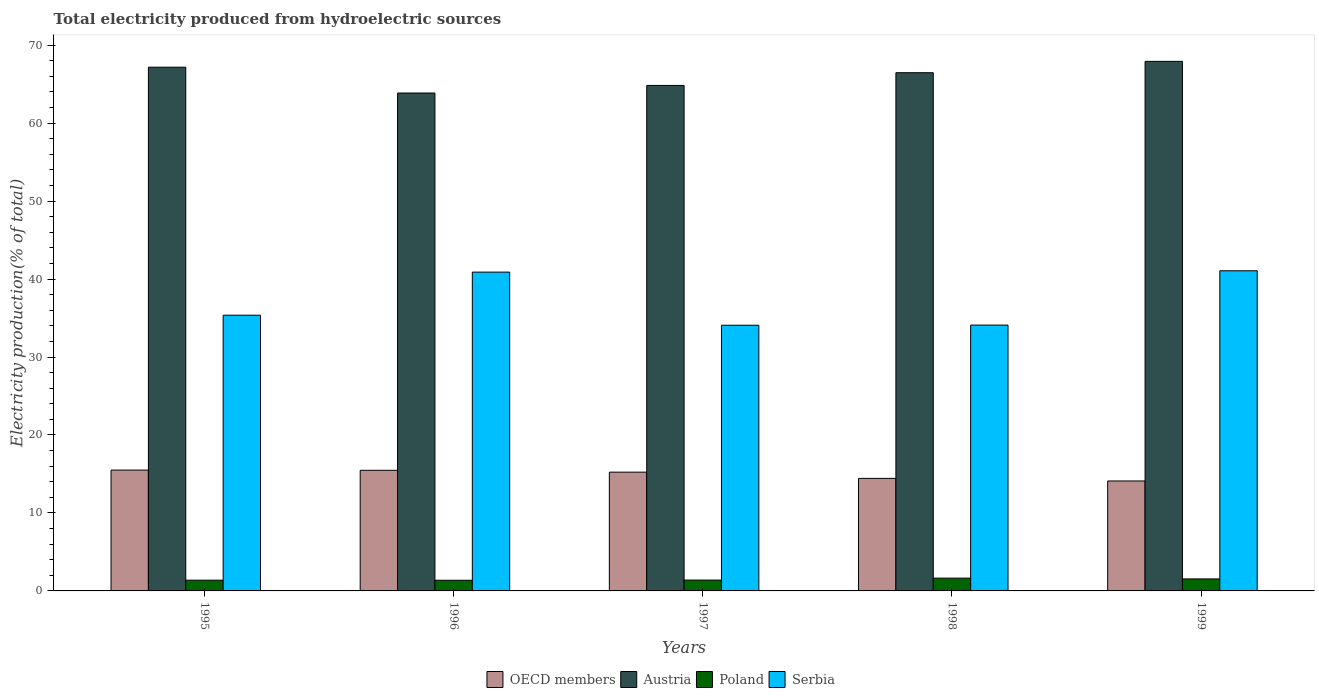Are the number of bars on each tick of the X-axis equal?
Make the answer very short. Yes. How many bars are there on the 3rd tick from the left?
Offer a terse response. 4. What is the label of the 1st group of bars from the left?
Ensure brevity in your answer.  1995. In how many cases, is the number of bars for a given year not equal to the number of legend labels?
Provide a succinct answer. 0. What is the total electricity produced in Poland in 1996?
Keep it short and to the point. 1.37. Across all years, what is the maximum total electricity produced in Poland?
Your answer should be very brief. 1.64. Across all years, what is the minimum total electricity produced in Serbia?
Your response must be concise. 34.08. In which year was the total electricity produced in Serbia maximum?
Give a very brief answer. 1999. What is the total total electricity produced in Poland in the graph?
Your answer should be compact. 7.32. What is the difference between the total electricity produced in Poland in 1996 and that in 1999?
Give a very brief answer. -0.17. What is the difference between the total electricity produced in Poland in 1997 and the total electricity produced in Serbia in 1996?
Provide a short and direct response. -39.5. What is the average total electricity produced in OECD members per year?
Offer a terse response. 14.95. In the year 1995, what is the difference between the total electricity produced in Poland and total electricity produced in OECD members?
Provide a succinct answer. -14.12. What is the ratio of the total electricity produced in Austria in 1996 to that in 1999?
Provide a succinct answer. 0.94. Is the total electricity produced in Serbia in 1997 less than that in 1999?
Provide a short and direct response. Yes. Is the difference between the total electricity produced in Poland in 1995 and 1997 greater than the difference between the total electricity produced in OECD members in 1995 and 1997?
Your answer should be compact. No. What is the difference between the highest and the second highest total electricity produced in Austria?
Offer a very short reply. 0.75. What is the difference between the highest and the lowest total electricity produced in OECD members?
Offer a terse response. 1.4. In how many years, is the total electricity produced in Serbia greater than the average total electricity produced in Serbia taken over all years?
Your response must be concise. 2. Is the sum of the total electricity produced in Poland in 1997 and 1998 greater than the maximum total electricity produced in OECD members across all years?
Your answer should be very brief. No. What does the 1st bar from the right in 1997 represents?
Your response must be concise. Serbia. Is it the case that in every year, the sum of the total electricity produced in Poland and total electricity produced in Serbia is greater than the total electricity produced in Austria?
Your response must be concise. No. Are all the bars in the graph horizontal?
Your response must be concise. No. What is the difference between two consecutive major ticks on the Y-axis?
Ensure brevity in your answer.  10. Does the graph contain grids?
Ensure brevity in your answer.  No. How many legend labels are there?
Offer a very short reply. 4. How are the legend labels stacked?
Provide a succinct answer. Horizontal. What is the title of the graph?
Make the answer very short. Total electricity produced from hydroelectric sources. What is the label or title of the X-axis?
Keep it short and to the point. Years. What is the Electricity production(% of total) of OECD members in 1995?
Offer a terse response. 15.5. What is the Electricity production(% of total) in Austria in 1995?
Your answer should be compact. 67.18. What is the Electricity production(% of total) of Poland in 1995?
Your response must be concise. 1.38. What is the Electricity production(% of total) of Serbia in 1995?
Offer a very short reply. 35.37. What is the Electricity production(% of total) of OECD members in 1996?
Provide a short and direct response. 15.47. What is the Electricity production(% of total) in Austria in 1996?
Provide a succinct answer. 63.87. What is the Electricity production(% of total) of Poland in 1996?
Your answer should be compact. 1.37. What is the Electricity production(% of total) of Serbia in 1996?
Provide a succinct answer. 40.89. What is the Electricity production(% of total) of OECD members in 1997?
Make the answer very short. 15.24. What is the Electricity production(% of total) of Austria in 1997?
Offer a very short reply. 64.84. What is the Electricity production(% of total) of Poland in 1997?
Ensure brevity in your answer.  1.39. What is the Electricity production(% of total) of Serbia in 1997?
Offer a very short reply. 34.08. What is the Electricity production(% of total) in OECD members in 1998?
Provide a succinct answer. 14.44. What is the Electricity production(% of total) in Austria in 1998?
Offer a very short reply. 66.47. What is the Electricity production(% of total) in Poland in 1998?
Give a very brief answer. 1.64. What is the Electricity production(% of total) of Serbia in 1998?
Keep it short and to the point. 34.1. What is the Electricity production(% of total) in OECD members in 1999?
Ensure brevity in your answer.  14.1. What is the Electricity production(% of total) of Austria in 1999?
Give a very brief answer. 67.93. What is the Electricity production(% of total) of Poland in 1999?
Give a very brief answer. 1.54. What is the Electricity production(% of total) of Serbia in 1999?
Your response must be concise. 41.07. Across all years, what is the maximum Electricity production(% of total) of OECD members?
Offer a terse response. 15.5. Across all years, what is the maximum Electricity production(% of total) of Austria?
Provide a short and direct response. 67.93. Across all years, what is the maximum Electricity production(% of total) of Poland?
Your answer should be very brief. 1.64. Across all years, what is the maximum Electricity production(% of total) in Serbia?
Give a very brief answer. 41.07. Across all years, what is the minimum Electricity production(% of total) in OECD members?
Give a very brief answer. 14.1. Across all years, what is the minimum Electricity production(% of total) in Austria?
Offer a very short reply. 63.87. Across all years, what is the minimum Electricity production(% of total) in Poland?
Provide a succinct answer. 1.37. Across all years, what is the minimum Electricity production(% of total) in Serbia?
Your answer should be very brief. 34.08. What is the total Electricity production(% of total) of OECD members in the graph?
Your response must be concise. 74.75. What is the total Electricity production(% of total) in Austria in the graph?
Your answer should be compact. 330.28. What is the total Electricity production(% of total) in Poland in the graph?
Keep it short and to the point. 7.32. What is the total Electricity production(% of total) of Serbia in the graph?
Your answer should be very brief. 185.5. What is the difference between the Electricity production(% of total) of OECD members in 1995 and that in 1996?
Your answer should be compact. 0.03. What is the difference between the Electricity production(% of total) in Austria in 1995 and that in 1996?
Provide a short and direct response. 3.31. What is the difference between the Electricity production(% of total) in Poland in 1995 and that in 1996?
Make the answer very short. 0.01. What is the difference between the Electricity production(% of total) of Serbia in 1995 and that in 1996?
Your response must be concise. -5.53. What is the difference between the Electricity production(% of total) of OECD members in 1995 and that in 1997?
Provide a short and direct response. 0.26. What is the difference between the Electricity production(% of total) in Austria in 1995 and that in 1997?
Provide a short and direct response. 2.34. What is the difference between the Electricity production(% of total) of Poland in 1995 and that in 1997?
Your response must be concise. -0.01. What is the difference between the Electricity production(% of total) in Serbia in 1995 and that in 1997?
Give a very brief answer. 1.29. What is the difference between the Electricity production(% of total) of OECD members in 1995 and that in 1998?
Your answer should be very brief. 1.06. What is the difference between the Electricity production(% of total) of Austria in 1995 and that in 1998?
Give a very brief answer. 0.71. What is the difference between the Electricity production(% of total) in Poland in 1995 and that in 1998?
Offer a very short reply. -0.26. What is the difference between the Electricity production(% of total) in Serbia in 1995 and that in 1998?
Provide a succinct answer. 1.27. What is the difference between the Electricity production(% of total) in OECD members in 1995 and that in 1999?
Offer a very short reply. 1.4. What is the difference between the Electricity production(% of total) of Austria in 1995 and that in 1999?
Your answer should be compact. -0.75. What is the difference between the Electricity production(% of total) of Poland in 1995 and that in 1999?
Provide a short and direct response. -0.16. What is the difference between the Electricity production(% of total) in Serbia in 1995 and that in 1999?
Your answer should be very brief. -5.7. What is the difference between the Electricity production(% of total) of OECD members in 1996 and that in 1997?
Offer a very short reply. 0.24. What is the difference between the Electricity production(% of total) of Austria in 1996 and that in 1997?
Ensure brevity in your answer.  -0.97. What is the difference between the Electricity production(% of total) of Poland in 1996 and that in 1997?
Your response must be concise. -0.02. What is the difference between the Electricity production(% of total) in Serbia in 1996 and that in 1997?
Give a very brief answer. 6.81. What is the difference between the Electricity production(% of total) of OECD members in 1996 and that in 1998?
Ensure brevity in your answer.  1.04. What is the difference between the Electricity production(% of total) of Austria in 1996 and that in 1998?
Offer a very short reply. -2.6. What is the difference between the Electricity production(% of total) of Poland in 1996 and that in 1998?
Your answer should be compact. -0.27. What is the difference between the Electricity production(% of total) in Serbia in 1996 and that in 1998?
Keep it short and to the point. 6.79. What is the difference between the Electricity production(% of total) of OECD members in 1996 and that in 1999?
Make the answer very short. 1.37. What is the difference between the Electricity production(% of total) of Austria in 1996 and that in 1999?
Keep it short and to the point. -4.06. What is the difference between the Electricity production(% of total) of Poland in 1996 and that in 1999?
Your answer should be very brief. -0.17. What is the difference between the Electricity production(% of total) in Serbia in 1996 and that in 1999?
Give a very brief answer. -0.17. What is the difference between the Electricity production(% of total) in OECD members in 1997 and that in 1998?
Offer a terse response. 0.8. What is the difference between the Electricity production(% of total) in Austria in 1997 and that in 1998?
Your answer should be compact. -1.63. What is the difference between the Electricity production(% of total) in Poland in 1997 and that in 1998?
Provide a short and direct response. -0.25. What is the difference between the Electricity production(% of total) in Serbia in 1997 and that in 1998?
Keep it short and to the point. -0.02. What is the difference between the Electricity production(% of total) of OECD members in 1997 and that in 1999?
Your answer should be very brief. 1.13. What is the difference between the Electricity production(% of total) in Austria in 1997 and that in 1999?
Your response must be concise. -3.09. What is the difference between the Electricity production(% of total) in Poland in 1997 and that in 1999?
Offer a very short reply. -0.15. What is the difference between the Electricity production(% of total) in Serbia in 1997 and that in 1999?
Provide a short and direct response. -6.99. What is the difference between the Electricity production(% of total) in OECD members in 1998 and that in 1999?
Provide a short and direct response. 0.33. What is the difference between the Electricity production(% of total) of Austria in 1998 and that in 1999?
Provide a succinct answer. -1.46. What is the difference between the Electricity production(% of total) of Poland in 1998 and that in 1999?
Give a very brief answer. 0.1. What is the difference between the Electricity production(% of total) in Serbia in 1998 and that in 1999?
Offer a very short reply. -6.97. What is the difference between the Electricity production(% of total) in OECD members in 1995 and the Electricity production(% of total) in Austria in 1996?
Offer a terse response. -48.37. What is the difference between the Electricity production(% of total) in OECD members in 1995 and the Electricity production(% of total) in Poland in 1996?
Offer a very short reply. 14.13. What is the difference between the Electricity production(% of total) in OECD members in 1995 and the Electricity production(% of total) in Serbia in 1996?
Ensure brevity in your answer.  -25.39. What is the difference between the Electricity production(% of total) of Austria in 1995 and the Electricity production(% of total) of Poland in 1996?
Provide a short and direct response. 65.81. What is the difference between the Electricity production(% of total) in Austria in 1995 and the Electricity production(% of total) in Serbia in 1996?
Offer a terse response. 26.28. What is the difference between the Electricity production(% of total) in Poland in 1995 and the Electricity production(% of total) in Serbia in 1996?
Provide a succinct answer. -39.52. What is the difference between the Electricity production(% of total) in OECD members in 1995 and the Electricity production(% of total) in Austria in 1997?
Give a very brief answer. -49.34. What is the difference between the Electricity production(% of total) of OECD members in 1995 and the Electricity production(% of total) of Poland in 1997?
Your answer should be very brief. 14.11. What is the difference between the Electricity production(% of total) in OECD members in 1995 and the Electricity production(% of total) in Serbia in 1997?
Offer a terse response. -18.58. What is the difference between the Electricity production(% of total) of Austria in 1995 and the Electricity production(% of total) of Poland in 1997?
Make the answer very short. 65.79. What is the difference between the Electricity production(% of total) of Austria in 1995 and the Electricity production(% of total) of Serbia in 1997?
Offer a terse response. 33.1. What is the difference between the Electricity production(% of total) of Poland in 1995 and the Electricity production(% of total) of Serbia in 1997?
Offer a very short reply. -32.7. What is the difference between the Electricity production(% of total) of OECD members in 1995 and the Electricity production(% of total) of Austria in 1998?
Your response must be concise. -50.97. What is the difference between the Electricity production(% of total) in OECD members in 1995 and the Electricity production(% of total) in Poland in 1998?
Provide a short and direct response. 13.86. What is the difference between the Electricity production(% of total) of OECD members in 1995 and the Electricity production(% of total) of Serbia in 1998?
Offer a very short reply. -18.6. What is the difference between the Electricity production(% of total) of Austria in 1995 and the Electricity production(% of total) of Poland in 1998?
Give a very brief answer. 65.54. What is the difference between the Electricity production(% of total) in Austria in 1995 and the Electricity production(% of total) in Serbia in 1998?
Provide a succinct answer. 33.08. What is the difference between the Electricity production(% of total) in Poland in 1995 and the Electricity production(% of total) in Serbia in 1998?
Provide a short and direct response. -32.72. What is the difference between the Electricity production(% of total) in OECD members in 1995 and the Electricity production(% of total) in Austria in 1999?
Your answer should be compact. -52.43. What is the difference between the Electricity production(% of total) in OECD members in 1995 and the Electricity production(% of total) in Poland in 1999?
Your answer should be very brief. 13.96. What is the difference between the Electricity production(% of total) of OECD members in 1995 and the Electricity production(% of total) of Serbia in 1999?
Make the answer very short. -25.57. What is the difference between the Electricity production(% of total) in Austria in 1995 and the Electricity production(% of total) in Poland in 1999?
Provide a succinct answer. 65.64. What is the difference between the Electricity production(% of total) in Austria in 1995 and the Electricity production(% of total) in Serbia in 1999?
Your answer should be very brief. 26.11. What is the difference between the Electricity production(% of total) of Poland in 1995 and the Electricity production(% of total) of Serbia in 1999?
Offer a terse response. -39.69. What is the difference between the Electricity production(% of total) of OECD members in 1996 and the Electricity production(% of total) of Austria in 1997?
Offer a terse response. -49.37. What is the difference between the Electricity production(% of total) of OECD members in 1996 and the Electricity production(% of total) of Poland in 1997?
Your response must be concise. 14.08. What is the difference between the Electricity production(% of total) in OECD members in 1996 and the Electricity production(% of total) in Serbia in 1997?
Offer a terse response. -18.61. What is the difference between the Electricity production(% of total) in Austria in 1996 and the Electricity production(% of total) in Poland in 1997?
Offer a very short reply. 62.48. What is the difference between the Electricity production(% of total) in Austria in 1996 and the Electricity production(% of total) in Serbia in 1997?
Make the answer very short. 29.79. What is the difference between the Electricity production(% of total) of Poland in 1996 and the Electricity production(% of total) of Serbia in 1997?
Offer a very short reply. -32.71. What is the difference between the Electricity production(% of total) of OECD members in 1996 and the Electricity production(% of total) of Austria in 1998?
Your answer should be very brief. -51. What is the difference between the Electricity production(% of total) of OECD members in 1996 and the Electricity production(% of total) of Poland in 1998?
Your answer should be compact. 13.83. What is the difference between the Electricity production(% of total) of OECD members in 1996 and the Electricity production(% of total) of Serbia in 1998?
Make the answer very short. -18.63. What is the difference between the Electricity production(% of total) of Austria in 1996 and the Electricity production(% of total) of Poland in 1998?
Keep it short and to the point. 62.23. What is the difference between the Electricity production(% of total) in Austria in 1996 and the Electricity production(% of total) in Serbia in 1998?
Offer a very short reply. 29.77. What is the difference between the Electricity production(% of total) of Poland in 1996 and the Electricity production(% of total) of Serbia in 1998?
Offer a very short reply. -32.73. What is the difference between the Electricity production(% of total) of OECD members in 1996 and the Electricity production(% of total) of Austria in 1999?
Keep it short and to the point. -52.46. What is the difference between the Electricity production(% of total) of OECD members in 1996 and the Electricity production(% of total) of Poland in 1999?
Offer a terse response. 13.93. What is the difference between the Electricity production(% of total) in OECD members in 1996 and the Electricity production(% of total) in Serbia in 1999?
Provide a short and direct response. -25.59. What is the difference between the Electricity production(% of total) of Austria in 1996 and the Electricity production(% of total) of Poland in 1999?
Give a very brief answer. 62.33. What is the difference between the Electricity production(% of total) of Austria in 1996 and the Electricity production(% of total) of Serbia in 1999?
Offer a very short reply. 22.8. What is the difference between the Electricity production(% of total) in Poland in 1996 and the Electricity production(% of total) in Serbia in 1999?
Offer a terse response. -39.7. What is the difference between the Electricity production(% of total) in OECD members in 1997 and the Electricity production(% of total) in Austria in 1998?
Keep it short and to the point. -51.23. What is the difference between the Electricity production(% of total) in OECD members in 1997 and the Electricity production(% of total) in Poland in 1998?
Keep it short and to the point. 13.6. What is the difference between the Electricity production(% of total) in OECD members in 1997 and the Electricity production(% of total) in Serbia in 1998?
Ensure brevity in your answer.  -18.86. What is the difference between the Electricity production(% of total) of Austria in 1997 and the Electricity production(% of total) of Poland in 1998?
Provide a succinct answer. 63.2. What is the difference between the Electricity production(% of total) of Austria in 1997 and the Electricity production(% of total) of Serbia in 1998?
Ensure brevity in your answer.  30.74. What is the difference between the Electricity production(% of total) of Poland in 1997 and the Electricity production(% of total) of Serbia in 1998?
Give a very brief answer. -32.71. What is the difference between the Electricity production(% of total) in OECD members in 1997 and the Electricity production(% of total) in Austria in 1999?
Offer a terse response. -52.69. What is the difference between the Electricity production(% of total) of OECD members in 1997 and the Electricity production(% of total) of Poland in 1999?
Keep it short and to the point. 13.7. What is the difference between the Electricity production(% of total) of OECD members in 1997 and the Electricity production(% of total) of Serbia in 1999?
Your answer should be very brief. -25.83. What is the difference between the Electricity production(% of total) of Austria in 1997 and the Electricity production(% of total) of Poland in 1999?
Offer a very short reply. 63.3. What is the difference between the Electricity production(% of total) of Austria in 1997 and the Electricity production(% of total) of Serbia in 1999?
Give a very brief answer. 23.77. What is the difference between the Electricity production(% of total) of Poland in 1997 and the Electricity production(% of total) of Serbia in 1999?
Provide a short and direct response. -39.67. What is the difference between the Electricity production(% of total) of OECD members in 1998 and the Electricity production(% of total) of Austria in 1999?
Offer a terse response. -53.49. What is the difference between the Electricity production(% of total) of OECD members in 1998 and the Electricity production(% of total) of Poland in 1999?
Keep it short and to the point. 12.9. What is the difference between the Electricity production(% of total) of OECD members in 1998 and the Electricity production(% of total) of Serbia in 1999?
Your answer should be very brief. -26.63. What is the difference between the Electricity production(% of total) in Austria in 1998 and the Electricity production(% of total) in Poland in 1999?
Your response must be concise. 64.93. What is the difference between the Electricity production(% of total) of Austria in 1998 and the Electricity production(% of total) of Serbia in 1999?
Make the answer very short. 25.4. What is the difference between the Electricity production(% of total) in Poland in 1998 and the Electricity production(% of total) in Serbia in 1999?
Ensure brevity in your answer.  -39.43. What is the average Electricity production(% of total) in OECD members per year?
Provide a succinct answer. 14.95. What is the average Electricity production(% of total) in Austria per year?
Give a very brief answer. 66.06. What is the average Electricity production(% of total) in Poland per year?
Ensure brevity in your answer.  1.46. What is the average Electricity production(% of total) of Serbia per year?
Keep it short and to the point. 37.1. In the year 1995, what is the difference between the Electricity production(% of total) in OECD members and Electricity production(% of total) in Austria?
Provide a short and direct response. -51.68. In the year 1995, what is the difference between the Electricity production(% of total) in OECD members and Electricity production(% of total) in Poland?
Provide a succinct answer. 14.12. In the year 1995, what is the difference between the Electricity production(% of total) in OECD members and Electricity production(% of total) in Serbia?
Your response must be concise. -19.87. In the year 1995, what is the difference between the Electricity production(% of total) of Austria and Electricity production(% of total) of Poland?
Ensure brevity in your answer.  65.8. In the year 1995, what is the difference between the Electricity production(% of total) in Austria and Electricity production(% of total) in Serbia?
Your answer should be compact. 31.81. In the year 1995, what is the difference between the Electricity production(% of total) of Poland and Electricity production(% of total) of Serbia?
Provide a short and direct response. -33.99. In the year 1996, what is the difference between the Electricity production(% of total) in OECD members and Electricity production(% of total) in Austria?
Your answer should be compact. -48.4. In the year 1996, what is the difference between the Electricity production(% of total) of OECD members and Electricity production(% of total) of Poland?
Offer a terse response. 14.1. In the year 1996, what is the difference between the Electricity production(% of total) in OECD members and Electricity production(% of total) in Serbia?
Offer a very short reply. -25.42. In the year 1996, what is the difference between the Electricity production(% of total) of Austria and Electricity production(% of total) of Poland?
Provide a short and direct response. 62.5. In the year 1996, what is the difference between the Electricity production(% of total) of Austria and Electricity production(% of total) of Serbia?
Your answer should be compact. 22.97. In the year 1996, what is the difference between the Electricity production(% of total) in Poland and Electricity production(% of total) in Serbia?
Provide a succinct answer. -39.52. In the year 1997, what is the difference between the Electricity production(% of total) of OECD members and Electricity production(% of total) of Austria?
Provide a succinct answer. -49.6. In the year 1997, what is the difference between the Electricity production(% of total) in OECD members and Electricity production(% of total) in Poland?
Offer a terse response. 13.84. In the year 1997, what is the difference between the Electricity production(% of total) of OECD members and Electricity production(% of total) of Serbia?
Your answer should be compact. -18.84. In the year 1997, what is the difference between the Electricity production(% of total) of Austria and Electricity production(% of total) of Poland?
Offer a very short reply. 63.45. In the year 1997, what is the difference between the Electricity production(% of total) in Austria and Electricity production(% of total) in Serbia?
Offer a very short reply. 30.76. In the year 1997, what is the difference between the Electricity production(% of total) of Poland and Electricity production(% of total) of Serbia?
Your answer should be compact. -32.69. In the year 1998, what is the difference between the Electricity production(% of total) of OECD members and Electricity production(% of total) of Austria?
Your answer should be compact. -52.03. In the year 1998, what is the difference between the Electricity production(% of total) of OECD members and Electricity production(% of total) of Poland?
Your response must be concise. 12.8. In the year 1998, what is the difference between the Electricity production(% of total) of OECD members and Electricity production(% of total) of Serbia?
Provide a short and direct response. -19.66. In the year 1998, what is the difference between the Electricity production(% of total) of Austria and Electricity production(% of total) of Poland?
Provide a succinct answer. 64.83. In the year 1998, what is the difference between the Electricity production(% of total) in Austria and Electricity production(% of total) in Serbia?
Your answer should be compact. 32.37. In the year 1998, what is the difference between the Electricity production(% of total) in Poland and Electricity production(% of total) in Serbia?
Make the answer very short. -32.46. In the year 1999, what is the difference between the Electricity production(% of total) in OECD members and Electricity production(% of total) in Austria?
Offer a very short reply. -53.82. In the year 1999, what is the difference between the Electricity production(% of total) of OECD members and Electricity production(% of total) of Poland?
Provide a succinct answer. 12.56. In the year 1999, what is the difference between the Electricity production(% of total) in OECD members and Electricity production(% of total) in Serbia?
Provide a short and direct response. -26.96. In the year 1999, what is the difference between the Electricity production(% of total) of Austria and Electricity production(% of total) of Poland?
Your answer should be very brief. 66.39. In the year 1999, what is the difference between the Electricity production(% of total) in Austria and Electricity production(% of total) in Serbia?
Your answer should be very brief. 26.86. In the year 1999, what is the difference between the Electricity production(% of total) in Poland and Electricity production(% of total) in Serbia?
Provide a short and direct response. -39.53. What is the ratio of the Electricity production(% of total) of Austria in 1995 to that in 1996?
Offer a terse response. 1.05. What is the ratio of the Electricity production(% of total) in Poland in 1995 to that in 1996?
Offer a terse response. 1.01. What is the ratio of the Electricity production(% of total) in Serbia in 1995 to that in 1996?
Offer a very short reply. 0.86. What is the ratio of the Electricity production(% of total) in OECD members in 1995 to that in 1997?
Offer a terse response. 1.02. What is the ratio of the Electricity production(% of total) of Austria in 1995 to that in 1997?
Offer a terse response. 1.04. What is the ratio of the Electricity production(% of total) of Poland in 1995 to that in 1997?
Offer a very short reply. 0.99. What is the ratio of the Electricity production(% of total) of Serbia in 1995 to that in 1997?
Offer a terse response. 1.04. What is the ratio of the Electricity production(% of total) in OECD members in 1995 to that in 1998?
Make the answer very short. 1.07. What is the ratio of the Electricity production(% of total) in Austria in 1995 to that in 1998?
Ensure brevity in your answer.  1.01. What is the ratio of the Electricity production(% of total) in Poland in 1995 to that in 1998?
Provide a succinct answer. 0.84. What is the ratio of the Electricity production(% of total) in Serbia in 1995 to that in 1998?
Provide a short and direct response. 1.04. What is the ratio of the Electricity production(% of total) in OECD members in 1995 to that in 1999?
Your answer should be compact. 1.1. What is the ratio of the Electricity production(% of total) of Poland in 1995 to that in 1999?
Make the answer very short. 0.89. What is the ratio of the Electricity production(% of total) of Serbia in 1995 to that in 1999?
Give a very brief answer. 0.86. What is the ratio of the Electricity production(% of total) in OECD members in 1996 to that in 1997?
Provide a short and direct response. 1.02. What is the ratio of the Electricity production(% of total) in Austria in 1996 to that in 1997?
Your answer should be very brief. 0.98. What is the ratio of the Electricity production(% of total) in Poland in 1996 to that in 1997?
Provide a short and direct response. 0.98. What is the ratio of the Electricity production(% of total) in Serbia in 1996 to that in 1997?
Give a very brief answer. 1.2. What is the ratio of the Electricity production(% of total) in OECD members in 1996 to that in 1998?
Ensure brevity in your answer.  1.07. What is the ratio of the Electricity production(% of total) of Austria in 1996 to that in 1998?
Make the answer very short. 0.96. What is the ratio of the Electricity production(% of total) of Poland in 1996 to that in 1998?
Provide a succinct answer. 0.83. What is the ratio of the Electricity production(% of total) of Serbia in 1996 to that in 1998?
Provide a succinct answer. 1.2. What is the ratio of the Electricity production(% of total) of OECD members in 1996 to that in 1999?
Your answer should be very brief. 1.1. What is the ratio of the Electricity production(% of total) of Austria in 1996 to that in 1999?
Your response must be concise. 0.94. What is the ratio of the Electricity production(% of total) in Poland in 1996 to that in 1999?
Your answer should be compact. 0.89. What is the ratio of the Electricity production(% of total) of Serbia in 1996 to that in 1999?
Give a very brief answer. 1. What is the ratio of the Electricity production(% of total) of OECD members in 1997 to that in 1998?
Offer a terse response. 1.06. What is the ratio of the Electricity production(% of total) in Austria in 1997 to that in 1998?
Your answer should be compact. 0.98. What is the ratio of the Electricity production(% of total) in Poland in 1997 to that in 1998?
Keep it short and to the point. 0.85. What is the ratio of the Electricity production(% of total) of OECD members in 1997 to that in 1999?
Your response must be concise. 1.08. What is the ratio of the Electricity production(% of total) in Austria in 1997 to that in 1999?
Your response must be concise. 0.95. What is the ratio of the Electricity production(% of total) of Poland in 1997 to that in 1999?
Provide a short and direct response. 0.9. What is the ratio of the Electricity production(% of total) of Serbia in 1997 to that in 1999?
Your answer should be compact. 0.83. What is the ratio of the Electricity production(% of total) in OECD members in 1998 to that in 1999?
Provide a short and direct response. 1.02. What is the ratio of the Electricity production(% of total) in Austria in 1998 to that in 1999?
Your answer should be compact. 0.98. What is the ratio of the Electricity production(% of total) in Poland in 1998 to that in 1999?
Offer a terse response. 1.07. What is the ratio of the Electricity production(% of total) of Serbia in 1998 to that in 1999?
Offer a terse response. 0.83. What is the difference between the highest and the second highest Electricity production(% of total) in OECD members?
Make the answer very short. 0.03. What is the difference between the highest and the second highest Electricity production(% of total) of Austria?
Offer a terse response. 0.75. What is the difference between the highest and the second highest Electricity production(% of total) in Poland?
Offer a very short reply. 0.1. What is the difference between the highest and the second highest Electricity production(% of total) of Serbia?
Keep it short and to the point. 0.17. What is the difference between the highest and the lowest Electricity production(% of total) in OECD members?
Offer a terse response. 1.4. What is the difference between the highest and the lowest Electricity production(% of total) in Austria?
Ensure brevity in your answer.  4.06. What is the difference between the highest and the lowest Electricity production(% of total) of Poland?
Offer a terse response. 0.27. What is the difference between the highest and the lowest Electricity production(% of total) in Serbia?
Your answer should be very brief. 6.99. 